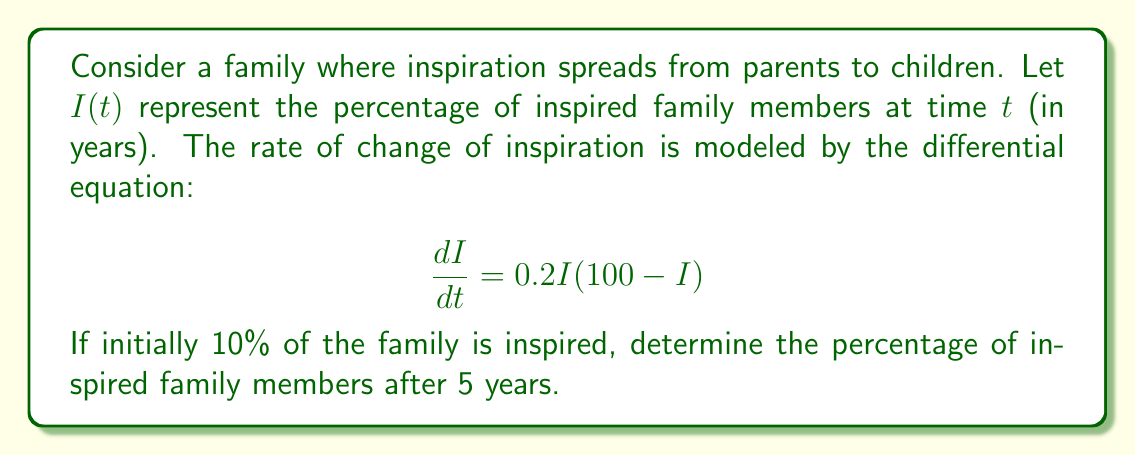Provide a solution to this math problem. To solve this problem, we need to follow these steps:

1) Recognize the differential equation as a logistic growth model:
   $$\frac{dI}{dt} = kI(M-I)$$
   where $k=0.2$ and $M=100$ (the maximum percentage).

2) The general solution to this logistic equation is:
   $$I(t) = \frac{M}{1 + Ce^{-kMt}}$$
   where $C$ is a constant determined by the initial condition.

3) Given the initial condition $I(0) = 10$, we can find $C$:
   $$10 = \frac{100}{1 + C}$$
   $$C = 9$$

4) Now we have the particular solution:
   $$I(t) = \frac{100}{1 + 9e^{-20t}}$$

5) To find the percentage after 5 years, we evaluate $I(5)$:
   $$I(5) = \frac{100}{1 + 9e^{-20(5)}}$$
   $$= \frac{100}{1 + 9e^{-100}}$$
   $$\approx 99.9999999\%$$

6) Rounding to two decimal places, we get 100.00%.

This rapid approach to 100% reflects how quickly inspiration can spread within a family when nurtured, aligning with the mother's desire to inspire her children to follow their passions.
Answer: After 5 years, approximately 100.00% of the family members will be inspired. 